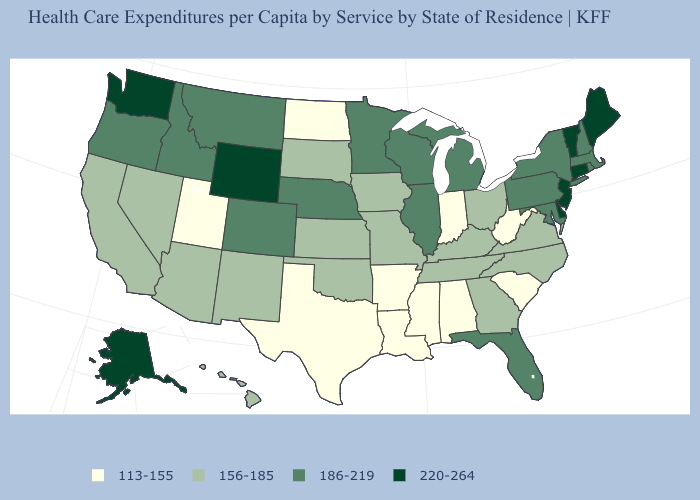Name the states that have a value in the range 156-185?
Quick response, please. Arizona, California, Georgia, Hawaii, Iowa, Kansas, Kentucky, Missouri, Nevada, New Mexico, North Carolina, Ohio, Oklahoma, South Dakota, Tennessee, Virginia. Does New Hampshire have the lowest value in the Northeast?
Keep it brief. Yes. Name the states that have a value in the range 156-185?
Keep it brief. Arizona, California, Georgia, Hawaii, Iowa, Kansas, Kentucky, Missouri, Nevada, New Mexico, North Carolina, Ohio, Oklahoma, South Dakota, Tennessee, Virginia. How many symbols are there in the legend?
Short answer required. 4. Does North Dakota have the lowest value in the MidWest?
Concise answer only. Yes. Does the first symbol in the legend represent the smallest category?
Keep it brief. Yes. Name the states that have a value in the range 220-264?
Concise answer only. Alaska, Connecticut, Delaware, Maine, New Jersey, Vermont, Washington, Wyoming. What is the lowest value in states that border Georgia?
Quick response, please. 113-155. Does Arkansas have a higher value than Nebraska?
Keep it brief. No. What is the lowest value in the USA?
Concise answer only. 113-155. Name the states that have a value in the range 186-219?
Short answer required. Colorado, Florida, Idaho, Illinois, Maryland, Massachusetts, Michigan, Minnesota, Montana, Nebraska, New Hampshire, New York, Oregon, Pennsylvania, Rhode Island, Wisconsin. What is the value of Colorado?
Concise answer only. 186-219. What is the value of Washington?
Answer briefly. 220-264. Which states have the highest value in the USA?
Quick response, please. Alaska, Connecticut, Delaware, Maine, New Jersey, Vermont, Washington, Wyoming. Does Delaware have the highest value in the USA?
Be succinct. Yes. 